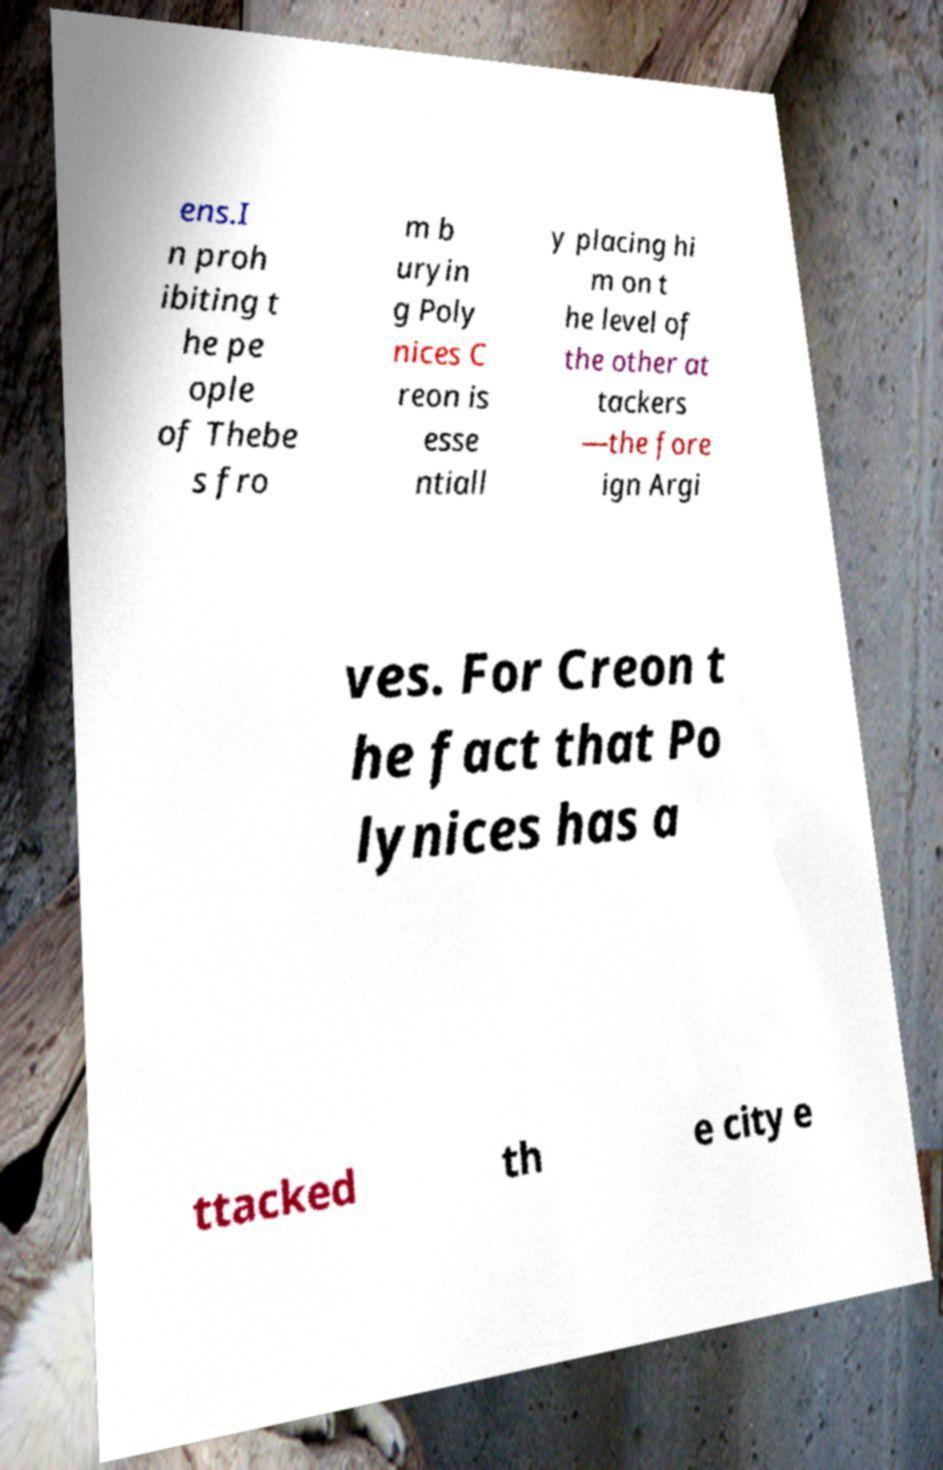There's text embedded in this image that I need extracted. Can you transcribe it verbatim? ens.I n proh ibiting t he pe ople of Thebe s fro m b uryin g Poly nices C reon is esse ntiall y placing hi m on t he level of the other at tackers —the fore ign Argi ves. For Creon t he fact that Po lynices has a ttacked th e city e 